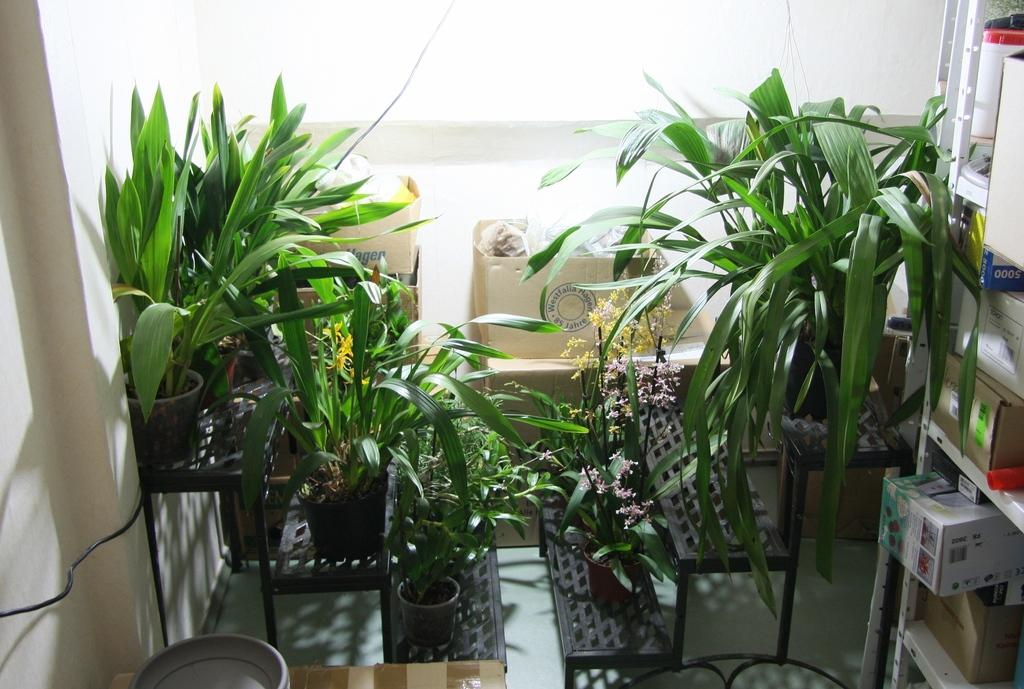What type of objects are in pots in the image? There are plants in pots in the image. What can be seen in the background of the image? There are boxes in the background of the image. Where are the boxes located in the image? The boxes are on shelves in the image. What type of haircut is the fish getting in the image? There is no fish or haircut present in the image. How much salt is visible in the image? There is no salt present in the image. 